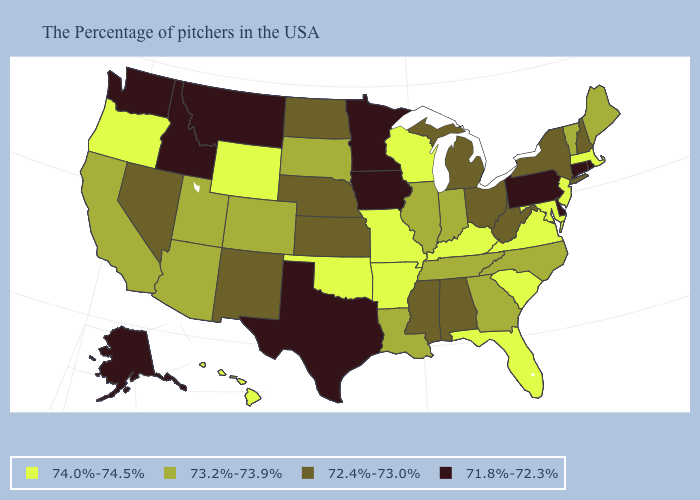Name the states that have a value in the range 72.4%-73.0%?
Give a very brief answer. New Hampshire, New York, West Virginia, Ohio, Michigan, Alabama, Mississippi, Kansas, Nebraska, North Dakota, New Mexico, Nevada. What is the highest value in the West ?
Be succinct. 74.0%-74.5%. What is the highest value in the MidWest ?
Be succinct. 74.0%-74.5%. Is the legend a continuous bar?
Keep it brief. No. What is the value of Oklahoma?
Be succinct. 74.0%-74.5%. What is the value of Maine?
Be succinct. 73.2%-73.9%. Name the states that have a value in the range 71.8%-72.3%?
Keep it brief. Rhode Island, Connecticut, Delaware, Pennsylvania, Minnesota, Iowa, Texas, Montana, Idaho, Washington, Alaska. What is the lowest value in the South?
Quick response, please. 71.8%-72.3%. Does the map have missing data?
Short answer required. No. Which states have the lowest value in the Northeast?
Concise answer only. Rhode Island, Connecticut, Pennsylvania. What is the lowest value in the West?
Give a very brief answer. 71.8%-72.3%. What is the lowest value in states that border Idaho?
Be succinct. 71.8%-72.3%. What is the value of Mississippi?
Answer briefly. 72.4%-73.0%. What is the value of North Carolina?
Answer briefly. 73.2%-73.9%. 